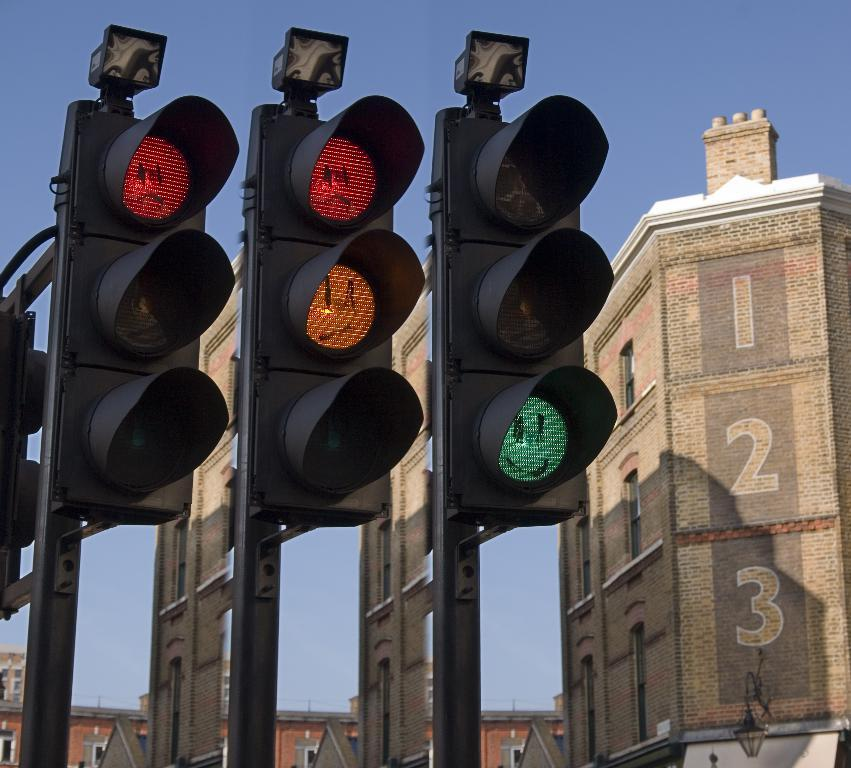<image>
Share a concise interpretation of the image provided. Three traffic lights by a building with 1 2 3 written on the side. 